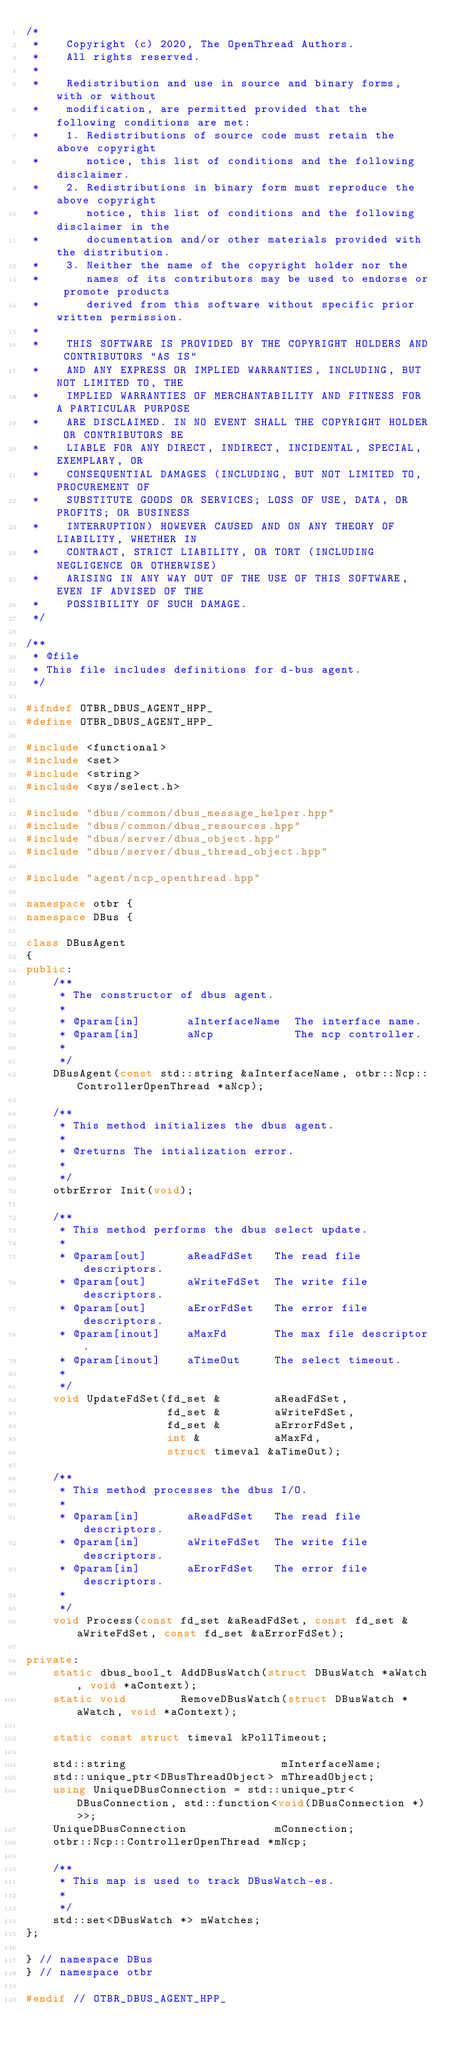<code> <loc_0><loc_0><loc_500><loc_500><_C++_>/*
 *    Copyright (c) 2020, The OpenThread Authors.
 *    All rights reserved.
 *
 *    Redistribution and use in source and binary forms, with or without
 *    modification, are permitted provided that the following conditions are met:
 *    1. Redistributions of source code must retain the above copyright
 *       notice, this list of conditions and the following disclaimer.
 *    2. Redistributions in binary form must reproduce the above copyright
 *       notice, this list of conditions and the following disclaimer in the
 *       documentation and/or other materials provided with the distribution.
 *    3. Neither the name of the copyright holder nor the
 *       names of its contributors may be used to endorse or promote products
 *       derived from this software without specific prior written permission.
 *
 *    THIS SOFTWARE IS PROVIDED BY THE COPYRIGHT HOLDERS AND CONTRIBUTORS "AS IS"
 *    AND ANY EXPRESS OR IMPLIED WARRANTIES, INCLUDING, BUT NOT LIMITED TO, THE
 *    IMPLIED WARRANTIES OF MERCHANTABILITY AND FITNESS FOR A PARTICULAR PURPOSE
 *    ARE DISCLAIMED. IN NO EVENT SHALL THE COPYRIGHT HOLDER OR CONTRIBUTORS BE
 *    LIABLE FOR ANY DIRECT, INDIRECT, INCIDENTAL, SPECIAL, EXEMPLARY, OR
 *    CONSEQUENTIAL DAMAGES (INCLUDING, BUT NOT LIMITED TO, PROCUREMENT OF
 *    SUBSTITUTE GOODS OR SERVICES; LOSS OF USE, DATA, OR PROFITS; OR BUSINESS
 *    INTERRUPTION) HOWEVER CAUSED AND ON ANY THEORY OF LIABILITY, WHETHER IN
 *    CONTRACT, STRICT LIABILITY, OR TORT (INCLUDING NEGLIGENCE OR OTHERWISE)
 *    ARISING IN ANY WAY OUT OF THE USE OF THIS SOFTWARE, EVEN IF ADVISED OF THE
 *    POSSIBILITY OF SUCH DAMAGE.
 */

/**
 * @file
 * This file includes definitions for d-bus agent.
 */

#ifndef OTBR_DBUS_AGENT_HPP_
#define OTBR_DBUS_AGENT_HPP_

#include <functional>
#include <set>
#include <string>
#include <sys/select.h>

#include "dbus/common/dbus_message_helper.hpp"
#include "dbus/common/dbus_resources.hpp"
#include "dbus/server/dbus_object.hpp"
#include "dbus/server/dbus_thread_object.hpp"

#include "agent/ncp_openthread.hpp"

namespace otbr {
namespace DBus {

class DBusAgent
{
public:
    /**
     * The constructor of dbus agent.
     *
     * @param[in]       aInterfaceName  The interface name.
     * @param[in]       aNcp            The ncp controller.
     *
     */
    DBusAgent(const std::string &aInterfaceName, otbr::Ncp::ControllerOpenThread *aNcp);

    /**
     * This method initializes the dbus agent.
     *
     * @returns The intialization error.
     *
     */
    otbrError Init(void);

    /**
     * This method performs the dbus select update.
     *
     * @param[out]      aReadFdSet   The read file descriptors.
     * @param[out]      aWriteFdSet  The write file descriptors.
     * @param[out]      aErorFdSet   The error file descriptors.
     * @param[inout]    aMaxFd       The max file descriptor.
     * @param[inout]    aTimeOut     The select timeout.
     *
     */
    void UpdateFdSet(fd_set &        aReadFdSet,
                     fd_set &        aWriteFdSet,
                     fd_set &        aErrorFdSet,
                     int &           aMaxFd,
                     struct timeval &aTimeOut);

    /**
     * This method processes the dbus I/O.
     *
     * @param[in]       aReadFdSet   The read file descriptors.
     * @param[in]       aWriteFdSet  The write file descriptors.
     * @param[in]       aErorFdSet   The error file descriptors.
     *
     */
    void Process(const fd_set &aReadFdSet, const fd_set &aWriteFdSet, const fd_set &aErrorFdSet);

private:
    static dbus_bool_t AddDBusWatch(struct DBusWatch *aWatch, void *aContext);
    static void        RemoveDBusWatch(struct DBusWatch *aWatch, void *aContext);

    static const struct timeval kPollTimeout;

    std::string                       mInterfaceName;
    std::unique_ptr<DBusThreadObject> mThreadObject;
    using UniqueDBusConnection = std::unique_ptr<DBusConnection, std::function<void(DBusConnection *)>>;
    UniqueDBusConnection             mConnection;
    otbr::Ncp::ControllerOpenThread *mNcp;

    /**
     * This map is used to track DBusWatch-es.
     *
     */
    std::set<DBusWatch *> mWatches;
};

} // namespace DBus
} // namespace otbr

#endif // OTBR_DBUS_AGENT_HPP_
</code> 